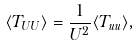Convert formula to latex. <formula><loc_0><loc_0><loc_500><loc_500>\langle T _ { U U } \rangle = \frac { 1 } { U ^ { 2 } } \langle T _ { u u } \rangle ,</formula> 